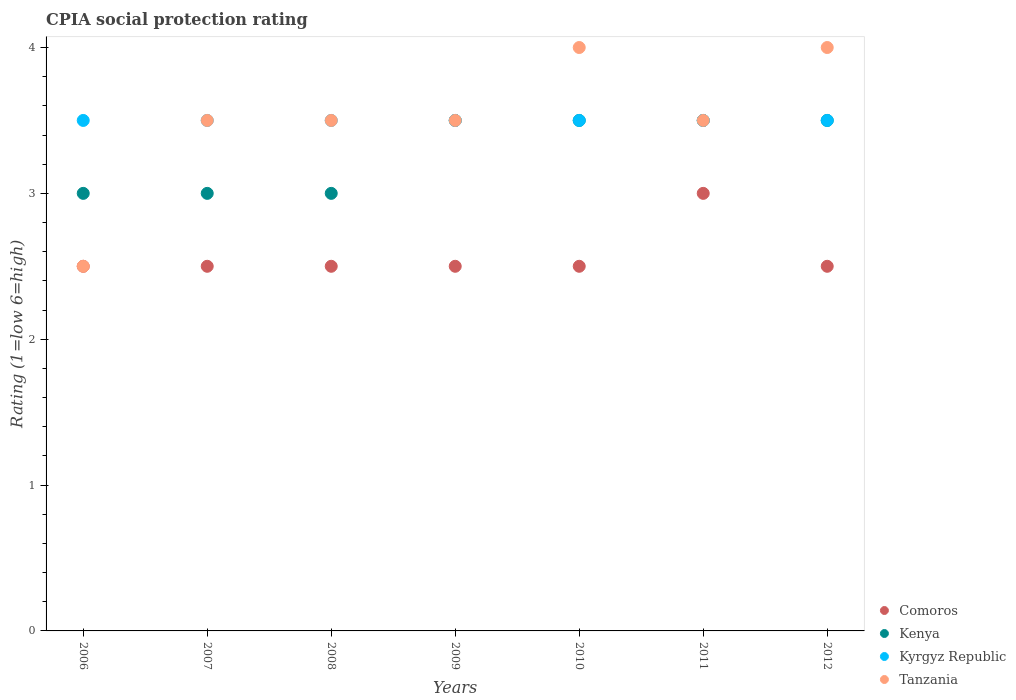How many different coloured dotlines are there?
Provide a succinct answer. 4. Is the number of dotlines equal to the number of legend labels?
Make the answer very short. Yes. Across all years, what is the maximum CPIA rating in Comoros?
Make the answer very short. 3. In which year was the CPIA rating in Tanzania maximum?
Your answer should be compact. 2010. What is the difference between the CPIA rating in Comoros in 2007 and that in 2012?
Provide a short and direct response. 0. What is the average CPIA rating in Comoros per year?
Your response must be concise. 2.57. In how many years, is the CPIA rating in Comoros greater than 2.4?
Your response must be concise. 7. Is the difference between the CPIA rating in Tanzania in 2006 and 2010 greater than the difference between the CPIA rating in Kyrgyz Republic in 2006 and 2010?
Keep it short and to the point. No. In how many years, is the CPIA rating in Comoros greater than the average CPIA rating in Comoros taken over all years?
Your answer should be very brief. 1. Is the sum of the CPIA rating in Kenya in 2007 and 2008 greater than the maximum CPIA rating in Kyrgyz Republic across all years?
Provide a short and direct response. Yes. Is it the case that in every year, the sum of the CPIA rating in Kyrgyz Republic and CPIA rating in Tanzania  is greater than the sum of CPIA rating in Comoros and CPIA rating in Kenya?
Provide a short and direct response. No. Does the CPIA rating in Comoros monotonically increase over the years?
Your answer should be very brief. No. Is the CPIA rating in Kyrgyz Republic strictly greater than the CPIA rating in Comoros over the years?
Your answer should be compact. Yes. Is the CPIA rating in Kenya strictly less than the CPIA rating in Comoros over the years?
Offer a very short reply. No. How many dotlines are there?
Make the answer very short. 4. Does the graph contain any zero values?
Make the answer very short. No. What is the title of the graph?
Offer a very short reply. CPIA social protection rating. What is the label or title of the X-axis?
Provide a succinct answer. Years. What is the label or title of the Y-axis?
Your answer should be very brief. Rating (1=low 6=high). What is the Rating (1=low 6=high) of Kenya in 2006?
Offer a terse response. 3. What is the Rating (1=low 6=high) of Kyrgyz Republic in 2006?
Provide a short and direct response. 3.5. What is the Rating (1=low 6=high) of Tanzania in 2006?
Your response must be concise. 2.5. What is the Rating (1=low 6=high) in Comoros in 2007?
Ensure brevity in your answer.  2.5. What is the Rating (1=low 6=high) of Kyrgyz Republic in 2007?
Ensure brevity in your answer.  3.5. What is the Rating (1=low 6=high) of Tanzania in 2008?
Provide a succinct answer. 3.5. What is the Rating (1=low 6=high) in Comoros in 2009?
Ensure brevity in your answer.  2.5. What is the Rating (1=low 6=high) of Kenya in 2010?
Your response must be concise. 3.5. What is the Rating (1=low 6=high) of Tanzania in 2010?
Give a very brief answer. 4. What is the Rating (1=low 6=high) in Kyrgyz Republic in 2011?
Your response must be concise. 3.5. What is the Rating (1=low 6=high) in Tanzania in 2011?
Your answer should be very brief. 3.5. What is the Rating (1=low 6=high) in Comoros in 2012?
Offer a terse response. 2.5. What is the Rating (1=low 6=high) in Kenya in 2012?
Your response must be concise. 3.5. What is the Rating (1=low 6=high) of Tanzania in 2012?
Offer a terse response. 4. Across all years, what is the maximum Rating (1=low 6=high) in Kenya?
Your answer should be very brief. 3.5. Across all years, what is the maximum Rating (1=low 6=high) in Kyrgyz Republic?
Offer a terse response. 3.5. Across all years, what is the minimum Rating (1=low 6=high) of Kyrgyz Republic?
Ensure brevity in your answer.  3.5. Across all years, what is the minimum Rating (1=low 6=high) in Tanzania?
Give a very brief answer. 2.5. What is the total Rating (1=low 6=high) in Comoros in the graph?
Your answer should be compact. 18. What is the total Rating (1=low 6=high) of Kyrgyz Republic in the graph?
Offer a very short reply. 24.5. What is the total Rating (1=low 6=high) of Tanzania in the graph?
Your response must be concise. 24.5. What is the difference between the Rating (1=low 6=high) of Comoros in 2006 and that in 2007?
Provide a succinct answer. 0. What is the difference between the Rating (1=low 6=high) of Kenya in 2006 and that in 2007?
Keep it short and to the point. 0. What is the difference between the Rating (1=low 6=high) of Kyrgyz Republic in 2006 and that in 2007?
Ensure brevity in your answer.  0. What is the difference between the Rating (1=low 6=high) in Tanzania in 2006 and that in 2007?
Offer a very short reply. -1. What is the difference between the Rating (1=low 6=high) of Kenya in 2006 and that in 2008?
Your answer should be very brief. 0. What is the difference between the Rating (1=low 6=high) in Kyrgyz Republic in 2006 and that in 2008?
Make the answer very short. 0. What is the difference between the Rating (1=low 6=high) of Kenya in 2006 and that in 2009?
Offer a very short reply. -0.5. What is the difference between the Rating (1=low 6=high) of Comoros in 2006 and that in 2010?
Offer a terse response. 0. What is the difference between the Rating (1=low 6=high) of Kenya in 2006 and that in 2010?
Keep it short and to the point. -0.5. What is the difference between the Rating (1=low 6=high) in Kyrgyz Republic in 2006 and that in 2010?
Your answer should be very brief. 0. What is the difference between the Rating (1=low 6=high) in Kenya in 2006 and that in 2011?
Offer a terse response. -0.5. What is the difference between the Rating (1=low 6=high) of Kyrgyz Republic in 2006 and that in 2011?
Keep it short and to the point. 0. What is the difference between the Rating (1=low 6=high) of Kenya in 2006 and that in 2012?
Provide a short and direct response. -0.5. What is the difference between the Rating (1=low 6=high) of Kyrgyz Republic in 2006 and that in 2012?
Provide a short and direct response. 0. What is the difference between the Rating (1=low 6=high) in Tanzania in 2006 and that in 2012?
Your answer should be compact. -1.5. What is the difference between the Rating (1=low 6=high) of Tanzania in 2007 and that in 2008?
Offer a very short reply. 0. What is the difference between the Rating (1=low 6=high) in Comoros in 2007 and that in 2009?
Offer a very short reply. 0. What is the difference between the Rating (1=low 6=high) of Kenya in 2007 and that in 2009?
Provide a short and direct response. -0.5. What is the difference between the Rating (1=low 6=high) of Tanzania in 2007 and that in 2009?
Provide a succinct answer. 0. What is the difference between the Rating (1=low 6=high) of Kyrgyz Republic in 2007 and that in 2010?
Your response must be concise. 0. What is the difference between the Rating (1=low 6=high) in Tanzania in 2007 and that in 2010?
Provide a succinct answer. -0.5. What is the difference between the Rating (1=low 6=high) in Kenya in 2007 and that in 2011?
Offer a very short reply. -0.5. What is the difference between the Rating (1=low 6=high) in Tanzania in 2007 and that in 2011?
Keep it short and to the point. 0. What is the difference between the Rating (1=low 6=high) in Kyrgyz Republic in 2007 and that in 2012?
Make the answer very short. 0. What is the difference between the Rating (1=low 6=high) in Tanzania in 2007 and that in 2012?
Provide a short and direct response. -0.5. What is the difference between the Rating (1=low 6=high) of Kyrgyz Republic in 2008 and that in 2009?
Provide a short and direct response. 0. What is the difference between the Rating (1=low 6=high) of Comoros in 2008 and that in 2010?
Your answer should be compact. 0. What is the difference between the Rating (1=low 6=high) of Kenya in 2008 and that in 2010?
Make the answer very short. -0.5. What is the difference between the Rating (1=low 6=high) in Tanzania in 2008 and that in 2011?
Your answer should be compact. 0. What is the difference between the Rating (1=low 6=high) of Comoros in 2008 and that in 2012?
Provide a succinct answer. 0. What is the difference between the Rating (1=low 6=high) in Kenya in 2008 and that in 2012?
Keep it short and to the point. -0.5. What is the difference between the Rating (1=low 6=high) of Tanzania in 2008 and that in 2012?
Ensure brevity in your answer.  -0.5. What is the difference between the Rating (1=low 6=high) in Comoros in 2009 and that in 2010?
Keep it short and to the point. 0. What is the difference between the Rating (1=low 6=high) in Tanzania in 2009 and that in 2010?
Make the answer very short. -0.5. What is the difference between the Rating (1=low 6=high) of Comoros in 2009 and that in 2011?
Your answer should be compact. -0.5. What is the difference between the Rating (1=low 6=high) in Kenya in 2009 and that in 2011?
Make the answer very short. 0. What is the difference between the Rating (1=low 6=high) of Kyrgyz Republic in 2009 and that in 2011?
Keep it short and to the point. 0. What is the difference between the Rating (1=low 6=high) in Kyrgyz Republic in 2010 and that in 2011?
Offer a terse response. 0. What is the difference between the Rating (1=low 6=high) in Tanzania in 2010 and that in 2011?
Offer a terse response. 0.5. What is the difference between the Rating (1=low 6=high) in Kenya in 2010 and that in 2012?
Make the answer very short. 0. What is the difference between the Rating (1=low 6=high) in Comoros in 2011 and that in 2012?
Offer a terse response. 0.5. What is the difference between the Rating (1=low 6=high) of Kenya in 2011 and that in 2012?
Your answer should be compact. 0. What is the difference between the Rating (1=low 6=high) in Comoros in 2006 and the Rating (1=low 6=high) in Kenya in 2007?
Your answer should be compact. -0.5. What is the difference between the Rating (1=low 6=high) of Kenya in 2006 and the Rating (1=low 6=high) of Tanzania in 2007?
Offer a very short reply. -0.5. What is the difference between the Rating (1=low 6=high) in Comoros in 2006 and the Rating (1=low 6=high) in Tanzania in 2008?
Offer a very short reply. -1. What is the difference between the Rating (1=low 6=high) in Kenya in 2006 and the Rating (1=low 6=high) in Kyrgyz Republic in 2008?
Your response must be concise. -0.5. What is the difference between the Rating (1=low 6=high) in Kenya in 2006 and the Rating (1=low 6=high) in Tanzania in 2008?
Keep it short and to the point. -0.5. What is the difference between the Rating (1=low 6=high) in Comoros in 2006 and the Rating (1=low 6=high) in Kenya in 2009?
Provide a short and direct response. -1. What is the difference between the Rating (1=low 6=high) in Kenya in 2006 and the Rating (1=low 6=high) in Kyrgyz Republic in 2009?
Your response must be concise. -0.5. What is the difference between the Rating (1=low 6=high) in Kyrgyz Republic in 2006 and the Rating (1=low 6=high) in Tanzania in 2009?
Provide a succinct answer. 0. What is the difference between the Rating (1=low 6=high) in Comoros in 2006 and the Rating (1=low 6=high) in Kenya in 2010?
Offer a very short reply. -1. What is the difference between the Rating (1=low 6=high) of Comoros in 2006 and the Rating (1=low 6=high) of Kyrgyz Republic in 2010?
Your answer should be very brief. -1. What is the difference between the Rating (1=low 6=high) of Comoros in 2006 and the Rating (1=low 6=high) of Tanzania in 2010?
Your answer should be compact. -1.5. What is the difference between the Rating (1=low 6=high) in Comoros in 2006 and the Rating (1=low 6=high) in Kenya in 2011?
Your answer should be very brief. -1. What is the difference between the Rating (1=low 6=high) in Comoros in 2006 and the Rating (1=low 6=high) in Kyrgyz Republic in 2011?
Provide a short and direct response. -1. What is the difference between the Rating (1=low 6=high) of Comoros in 2006 and the Rating (1=low 6=high) of Tanzania in 2011?
Provide a short and direct response. -1. What is the difference between the Rating (1=low 6=high) of Kenya in 2006 and the Rating (1=low 6=high) of Kyrgyz Republic in 2011?
Your answer should be very brief. -0.5. What is the difference between the Rating (1=low 6=high) in Kyrgyz Republic in 2006 and the Rating (1=low 6=high) in Tanzania in 2011?
Provide a short and direct response. 0. What is the difference between the Rating (1=low 6=high) of Comoros in 2006 and the Rating (1=low 6=high) of Kenya in 2012?
Your response must be concise. -1. What is the difference between the Rating (1=low 6=high) of Comoros in 2006 and the Rating (1=low 6=high) of Tanzania in 2012?
Your answer should be very brief. -1.5. What is the difference between the Rating (1=low 6=high) in Kenya in 2006 and the Rating (1=low 6=high) in Kyrgyz Republic in 2012?
Your answer should be very brief. -0.5. What is the difference between the Rating (1=low 6=high) of Kenya in 2006 and the Rating (1=low 6=high) of Tanzania in 2012?
Offer a terse response. -1. What is the difference between the Rating (1=low 6=high) of Comoros in 2007 and the Rating (1=low 6=high) of Kenya in 2008?
Offer a terse response. -0.5. What is the difference between the Rating (1=low 6=high) of Comoros in 2007 and the Rating (1=low 6=high) of Tanzania in 2008?
Keep it short and to the point. -1. What is the difference between the Rating (1=low 6=high) of Kenya in 2007 and the Rating (1=low 6=high) of Kyrgyz Republic in 2008?
Keep it short and to the point. -0.5. What is the difference between the Rating (1=low 6=high) of Kenya in 2007 and the Rating (1=low 6=high) of Kyrgyz Republic in 2009?
Give a very brief answer. -0.5. What is the difference between the Rating (1=low 6=high) of Kenya in 2007 and the Rating (1=low 6=high) of Tanzania in 2009?
Provide a short and direct response. -0.5. What is the difference between the Rating (1=low 6=high) of Comoros in 2007 and the Rating (1=low 6=high) of Kenya in 2010?
Your answer should be very brief. -1. What is the difference between the Rating (1=low 6=high) in Comoros in 2007 and the Rating (1=low 6=high) in Kyrgyz Republic in 2010?
Provide a succinct answer. -1. What is the difference between the Rating (1=low 6=high) of Kenya in 2007 and the Rating (1=low 6=high) of Tanzania in 2010?
Ensure brevity in your answer.  -1. What is the difference between the Rating (1=low 6=high) in Kyrgyz Republic in 2007 and the Rating (1=low 6=high) in Tanzania in 2010?
Offer a very short reply. -0.5. What is the difference between the Rating (1=low 6=high) in Comoros in 2007 and the Rating (1=low 6=high) in Kyrgyz Republic in 2011?
Provide a succinct answer. -1. What is the difference between the Rating (1=low 6=high) in Comoros in 2007 and the Rating (1=low 6=high) in Tanzania in 2011?
Your answer should be compact. -1. What is the difference between the Rating (1=low 6=high) in Kyrgyz Republic in 2007 and the Rating (1=low 6=high) in Tanzania in 2011?
Your response must be concise. 0. What is the difference between the Rating (1=low 6=high) in Comoros in 2007 and the Rating (1=low 6=high) in Kenya in 2012?
Provide a short and direct response. -1. What is the difference between the Rating (1=low 6=high) in Comoros in 2007 and the Rating (1=low 6=high) in Kyrgyz Republic in 2012?
Offer a terse response. -1. What is the difference between the Rating (1=low 6=high) in Kenya in 2007 and the Rating (1=low 6=high) in Kyrgyz Republic in 2012?
Your response must be concise. -0.5. What is the difference between the Rating (1=low 6=high) of Comoros in 2008 and the Rating (1=low 6=high) of Kenya in 2009?
Offer a terse response. -1. What is the difference between the Rating (1=low 6=high) of Kenya in 2008 and the Rating (1=low 6=high) of Kyrgyz Republic in 2009?
Your answer should be very brief. -0.5. What is the difference between the Rating (1=low 6=high) of Kyrgyz Republic in 2008 and the Rating (1=low 6=high) of Tanzania in 2009?
Offer a terse response. 0. What is the difference between the Rating (1=low 6=high) in Comoros in 2008 and the Rating (1=low 6=high) in Tanzania in 2010?
Offer a very short reply. -1.5. What is the difference between the Rating (1=low 6=high) in Kenya in 2008 and the Rating (1=low 6=high) in Kyrgyz Republic in 2010?
Make the answer very short. -0.5. What is the difference between the Rating (1=low 6=high) of Kyrgyz Republic in 2008 and the Rating (1=low 6=high) of Tanzania in 2010?
Ensure brevity in your answer.  -0.5. What is the difference between the Rating (1=low 6=high) in Comoros in 2008 and the Rating (1=low 6=high) in Kyrgyz Republic in 2011?
Ensure brevity in your answer.  -1. What is the difference between the Rating (1=low 6=high) in Kenya in 2008 and the Rating (1=low 6=high) in Tanzania in 2011?
Offer a terse response. -0.5. What is the difference between the Rating (1=low 6=high) of Kyrgyz Republic in 2008 and the Rating (1=low 6=high) of Tanzania in 2011?
Offer a very short reply. 0. What is the difference between the Rating (1=low 6=high) of Comoros in 2008 and the Rating (1=low 6=high) of Kenya in 2012?
Provide a succinct answer. -1. What is the difference between the Rating (1=low 6=high) of Comoros in 2008 and the Rating (1=low 6=high) of Kyrgyz Republic in 2012?
Provide a succinct answer. -1. What is the difference between the Rating (1=low 6=high) of Comoros in 2008 and the Rating (1=low 6=high) of Tanzania in 2012?
Offer a very short reply. -1.5. What is the difference between the Rating (1=low 6=high) of Kenya in 2008 and the Rating (1=low 6=high) of Tanzania in 2012?
Provide a short and direct response. -1. What is the difference between the Rating (1=low 6=high) in Comoros in 2009 and the Rating (1=low 6=high) in Tanzania in 2010?
Offer a very short reply. -1.5. What is the difference between the Rating (1=low 6=high) of Kenya in 2009 and the Rating (1=low 6=high) of Tanzania in 2010?
Make the answer very short. -0.5. What is the difference between the Rating (1=low 6=high) of Comoros in 2009 and the Rating (1=low 6=high) of Kenya in 2011?
Provide a short and direct response. -1. What is the difference between the Rating (1=low 6=high) of Comoros in 2009 and the Rating (1=low 6=high) of Tanzania in 2011?
Your response must be concise. -1. What is the difference between the Rating (1=low 6=high) in Kenya in 2009 and the Rating (1=low 6=high) in Kyrgyz Republic in 2011?
Your answer should be compact. 0. What is the difference between the Rating (1=low 6=high) of Kenya in 2009 and the Rating (1=low 6=high) of Tanzania in 2011?
Provide a short and direct response. 0. What is the difference between the Rating (1=low 6=high) of Kyrgyz Republic in 2009 and the Rating (1=low 6=high) of Tanzania in 2011?
Ensure brevity in your answer.  0. What is the difference between the Rating (1=low 6=high) of Comoros in 2009 and the Rating (1=low 6=high) of Kenya in 2012?
Your answer should be compact. -1. What is the difference between the Rating (1=low 6=high) in Comoros in 2009 and the Rating (1=low 6=high) in Kyrgyz Republic in 2012?
Offer a terse response. -1. What is the difference between the Rating (1=low 6=high) of Comoros in 2009 and the Rating (1=low 6=high) of Tanzania in 2012?
Ensure brevity in your answer.  -1.5. What is the difference between the Rating (1=low 6=high) of Kyrgyz Republic in 2009 and the Rating (1=low 6=high) of Tanzania in 2012?
Make the answer very short. -0.5. What is the difference between the Rating (1=low 6=high) in Kenya in 2010 and the Rating (1=low 6=high) in Kyrgyz Republic in 2011?
Make the answer very short. 0. What is the difference between the Rating (1=low 6=high) in Kenya in 2010 and the Rating (1=low 6=high) in Tanzania in 2011?
Your response must be concise. 0. What is the difference between the Rating (1=low 6=high) of Kyrgyz Republic in 2010 and the Rating (1=low 6=high) of Tanzania in 2011?
Offer a terse response. 0. What is the difference between the Rating (1=low 6=high) of Comoros in 2010 and the Rating (1=low 6=high) of Kyrgyz Republic in 2012?
Make the answer very short. -1. What is the difference between the Rating (1=low 6=high) in Comoros in 2010 and the Rating (1=low 6=high) in Tanzania in 2012?
Provide a short and direct response. -1.5. What is the difference between the Rating (1=low 6=high) in Kenya in 2010 and the Rating (1=low 6=high) in Kyrgyz Republic in 2012?
Offer a very short reply. 0. What is the difference between the Rating (1=low 6=high) in Kenya in 2010 and the Rating (1=low 6=high) in Tanzania in 2012?
Your answer should be compact. -0.5. What is the difference between the Rating (1=low 6=high) in Comoros in 2011 and the Rating (1=low 6=high) in Tanzania in 2012?
Keep it short and to the point. -1. What is the difference between the Rating (1=low 6=high) of Kenya in 2011 and the Rating (1=low 6=high) of Tanzania in 2012?
Give a very brief answer. -0.5. What is the difference between the Rating (1=low 6=high) in Kyrgyz Republic in 2011 and the Rating (1=low 6=high) in Tanzania in 2012?
Your response must be concise. -0.5. What is the average Rating (1=low 6=high) in Comoros per year?
Your answer should be very brief. 2.57. What is the average Rating (1=low 6=high) in Kenya per year?
Provide a succinct answer. 3.29. What is the average Rating (1=low 6=high) of Kyrgyz Republic per year?
Make the answer very short. 3.5. What is the average Rating (1=low 6=high) of Tanzania per year?
Your response must be concise. 3.5. In the year 2006, what is the difference between the Rating (1=low 6=high) in Comoros and Rating (1=low 6=high) in Kenya?
Give a very brief answer. -0.5. In the year 2006, what is the difference between the Rating (1=low 6=high) of Comoros and Rating (1=low 6=high) of Tanzania?
Your answer should be very brief. 0. In the year 2006, what is the difference between the Rating (1=low 6=high) in Kenya and Rating (1=low 6=high) in Kyrgyz Republic?
Provide a short and direct response. -0.5. In the year 2006, what is the difference between the Rating (1=low 6=high) in Kenya and Rating (1=low 6=high) in Tanzania?
Make the answer very short. 0.5. In the year 2007, what is the difference between the Rating (1=low 6=high) in Comoros and Rating (1=low 6=high) in Kenya?
Give a very brief answer. -0.5. In the year 2007, what is the difference between the Rating (1=low 6=high) of Kenya and Rating (1=low 6=high) of Kyrgyz Republic?
Offer a very short reply. -0.5. In the year 2008, what is the difference between the Rating (1=low 6=high) of Comoros and Rating (1=low 6=high) of Kyrgyz Republic?
Keep it short and to the point. -1. In the year 2008, what is the difference between the Rating (1=low 6=high) in Kenya and Rating (1=low 6=high) in Kyrgyz Republic?
Give a very brief answer. -0.5. In the year 2008, what is the difference between the Rating (1=low 6=high) of Kenya and Rating (1=low 6=high) of Tanzania?
Give a very brief answer. -0.5. In the year 2009, what is the difference between the Rating (1=low 6=high) of Comoros and Rating (1=low 6=high) of Kyrgyz Republic?
Make the answer very short. -1. In the year 2010, what is the difference between the Rating (1=low 6=high) in Kenya and Rating (1=low 6=high) in Tanzania?
Your answer should be compact. -0.5. In the year 2010, what is the difference between the Rating (1=low 6=high) of Kyrgyz Republic and Rating (1=low 6=high) of Tanzania?
Your answer should be very brief. -0.5. In the year 2011, what is the difference between the Rating (1=low 6=high) in Comoros and Rating (1=low 6=high) in Kenya?
Provide a short and direct response. -0.5. In the year 2011, what is the difference between the Rating (1=low 6=high) of Kenya and Rating (1=low 6=high) of Kyrgyz Republic?
Offer a terse response. 0. In the year 2011, what is the difference between the Rating (1=low 6=high) in Kenya and Rating (1=low 6=high) in Tanzania?
Your answer should be very brief. 0. In the year 2011, what is the difference between the Rating (1=low 6=high) of Kyrgyz Republic and Rating (1=low 6=high) of Tanzania?
Keep it short and to the point. 0. In the year 2012, what is the difference between the Rating (1=low 6=high) in Comoros and Rating (1=low 6=high) in Kyrgyz Republic?
Provide a succinct answer. -1. In the year 2012, what is the difference between the Rating (1=low 6=high) in Kenya and Rating (1=low 6=high) in Kyrgyz Republic?
Your answer should be very brief. 0. In the year 2012, what is the difference between the Rating (1=low 6=high) in Kenya and Rating (1=low 6=high) in Tanzania?
Offer a terse response. -0.5. What is the ratio of the Rating (1=low 6=high) in Comoros in 2006 to that in 2007?
Keep it short and to the point. 1. What is the ratio of the Rating (1=low 6=high) of Kyrgyz Republic in 2006 to that in 2007?
Give a very brief answer. 1. What is the ratio of the Rating (1=low 6=high) of Tanzania in 2006 to that in 2007?
Ensure brevity in your answer.  0.71. What is the ratio of the Rating (1=low 6=high) in Comoros in 2006 to that in 2008?
Give a very brief answer. 1. What is the ratio of the Rating (1=low 6=high) in Comoros in 2006 to that in 2009?
Make the answer very short. 1. What is the ratio of the Rating (1=low 6=high) in Kenya in 2006 to that in 2009?
Provide a short and direct response. 0.86. What is the ratio of the Rating (1=low 6=high) of Tanzania in 2006 to that in 2009?
Provide a succinct answer. 0.71. What is the ratio of the Rating (1=low 6=high) of Comoros in 2006 to that in 2010?
Offer a very short reply. 1. What is the ratio of the Rating (1=low 6=high) in Kenya in 2006 to that in 2010?
Your response must be concise. 0.86. What is the ratio of the Rating (1=low 6=high) in Kyrgyz Republic in 2006 to that in 2010?
Ensure brevity in your answer.  1. What is the ratio of the Rating (1=low 6=high) of Tanzania in 2006 to that in 2010?
Your response must be concise. 0.62. What is the ratio of the Rating (1=low 6=high) of Kenya in 2006 to that in 2011?
Your response must be concise. 0.86. What is the ratio of the Rating (1=low 6=high) in Kyrgyz Republic in 2006 to that in 2011?
Make the answer very short. 1. What is the ratio of the Rating (1=low 6=high) in Tanzania in 2006 to that in 2011?
Your response must be concise. 0.71. What is the ratio of the Rating (1=low 6=high) in Comoros in 2006 to that in 2012?
Provide a short and direct response. 1. What is the ratio of the Rating (1=low 6=high) in Kyrgyz Republic in 2006 to that in 2012?
Keep it short and to the point. 1. What is the ratio of the Rating (1=low 6=high) in Kenya in 2007 to that in 2008?
Offer a very short reply. 1. What is the ratio of the Rating (1=low 6=high) in Kyrgyz Republic in 2007 to that in 2008?
Make the answer very short. 1. What is the ratio of the Rating (1=low 6=high) in Tanzania in 2007 to that in 2008?
Your answer should be compact. 1. What is the ratio of the Rating (1=low 6=high) of Kenya in 2007 to that in 2009?
Your answer should be very brief. 0.86. What is the ratio of the Rating (1=low 6=high) of Comoros in 2007 to that in 2010?
Offer a very short reply. 1. What is the ratio of the Rating (1=low 6=high) in Kenya in 2007 to that in 2010?
Offer a terse response. 0.86. What is the ratio of the Rating (1=low 6=high) of Kyrgyz Republic in 2007 to that in 2010?
Give a very brief answer. 1. What is the ratio of the Rating (1=low 6=high) of Tanzania in 2007 to that in 2010?
Offer a terse response. 0.88. What is the ratio of the Rating (1=low 6=high) of Comoros in 2007 to that in 2011?
Offer a terse response. 0.83. What is the ratio of the Rating (1=low 6=high) of Kyrgyz Republic in 2007 to that in 2011?
Your answer should be very brief. 1. What is the ratio of the Rating (1=low 6=high) in Tanzania in 2007 to that in 2011?
Your answer should be very brief. 1. What is the ratio of the Rating (1=low 6=high) in Tanzania in 2007 to that in 2012?
Offer a terse response. 0.88. What is the ratio of the Rating (1=low 6=high) of Kyrgyz Republic in 2008 to that in 2009?
Provide a short and direct response. 1. What is the ratio of the Rating (1=low 6=high) in Comoros in 2008 to that in 2010?
Offer a terse response. 1. What is the ratio of the Rating (1=low 6=high) of Tanzania in 2008 to that in 2011?
Offer a very short reply. 1. What is the ratio of the Rating (1=low 6=high) of Kenya in 2009 to that in 2010?
Your response must be concise. 1. What is the ratio of the Rating (1=low 6=high) of Kyrgyz Republic in 2009 to that in 2010?
Make the answer very short. 1. What is the ratio of the Rating (1=low 6=high) in Tanzania in 2009 to that in 2010?
Your answer should be very brief. 0.88. What is the ratio of the Rating (1=low 6=high) in Kenya in 2009 to that in 2011?
Your answer should be very brief. 1. What is the ratio of the Rating (1=low 6=high) of Kyrgyz Republic in 2009 to that in 2011?
Offer a terse response. 1. What is the ratio of the Rating (1=low 6=high) in Kenya in 2009 to that in 2012?
Keep it short and to the point. 1. What is the ratio of the Rating (1=low 6=high) in Tanzania in 2009 to that in 2012?
Offer a very short reply. 0.88. What is the ratio of the Rating (1=low 6=high) in Kenya in 2010 to that in 2012?
Make the answer very short. 1. What is the ratio of the Rating (1=low 6=high) in Kenya in 2011 to that in 2012?
Make the answer very short. 1. What is the ratio of the Rating (1=low 6=high) in Tanzania in 2011 to that in 2012?
Offer a terse response. 0.88. What is the difference between the highest and the second highest Rating (1=low 6=high) in Kenya?
Your answer should be very brief. 0. What is the difference between the highest and the second highest Rating (1=low 6=high) in Tanzania?
Provide a short and direct response. 0. What is the difference between the highest and the lowest Rating (1=low 6=high) of Kenya?
Provide a short and direct response. 0.5. 